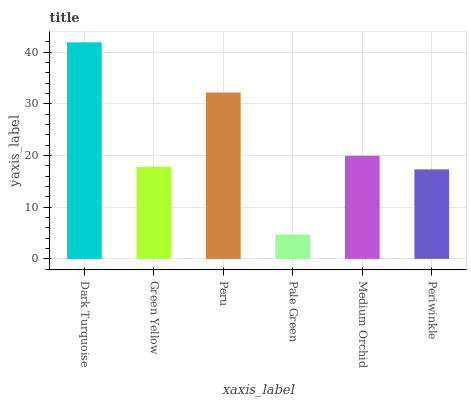Is Green Yellow the minimum?
Answer yes or no. No. Is Green Yellow the maximum?
Answer yes or no. No. Is Dark Turquoise greater than Green Yellow?
Answer yes or no. Yes. Is Green Yellow less than Dark Turquoise?
Answer yes or no. Yes. Is Green Yellow greater than Dark Turquoise?
Answer yes or no. No. Is Dark Turquoise less than Green Yellow?
Answer yes or no. No. Is Medium Orchid the high median?
Answer yes or no. Yes. Is Green Yellow the low median?
Answer yes or no. Yes. Is Green Yellow the high median?
Answer yes or no. No. Is Medium Orchid the low median?
Answer yes or no. No. 